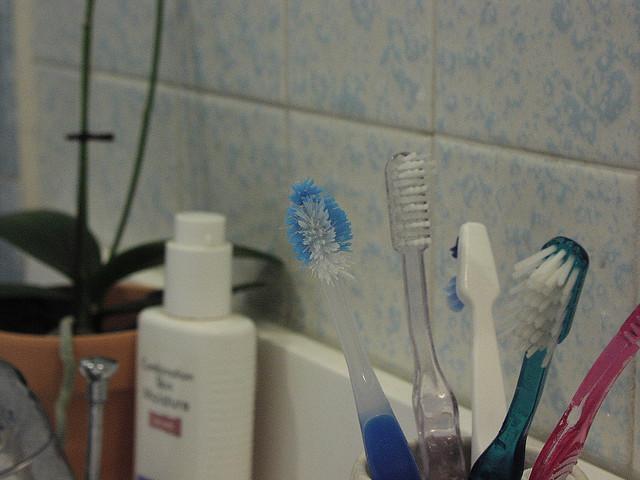How many toothbrushes are in this picture?
Give a very brief answer. 5. How many toothbrushes are in the cup?
Give a very brief answer. 5. How many plastic bottles are there in the picture?
Give a very brief answer. 1. How many toothbrushes?
Give a very brief answer. 5. How many toothbrushes are there?
Give a very brief answer. 5. 